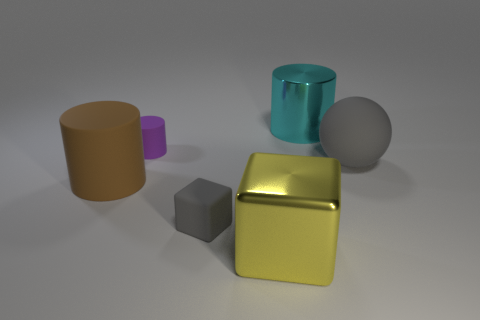There is a shiny object that is in front of the purple matte cylinder; what color is it?
Keep it short and to the point. Yellow. There is a shiny cylinder; does it have the same size as the gray thing on the left side of the large cyan metal object?
Keep it short and to the point. No. What size is the rubber thing that is on the left side of the metal cylinder and right of the purple cylinder?
Your response must be concise. Small. Is there a large yellow block that has the same material as the large cyan cylinder?
Offer a terse response. Yes. The large gray object has what shape?
Keep it short and to the point. Sphere. Is the metallic cube the same size as the purple rubber thing?
Your answer should be very brief. No. How many other objects are there of the same shape as the large cyan object?
Your answer should be compact. 2. There is a thing that is in front of the tiny gray matte cube; what shape is it?
Offer a very short reply. Cube. There is a tiny rubber object in front of the tiny purple rubber object; does it have the same shape as the brown thing on the left side of the large cyan cylinder?
Your answer should be very brief. No. Are there the same number of big rubber objects on the left side of the purple rubber thing and small gray blocks?
Your answer should be compact. Yes. 